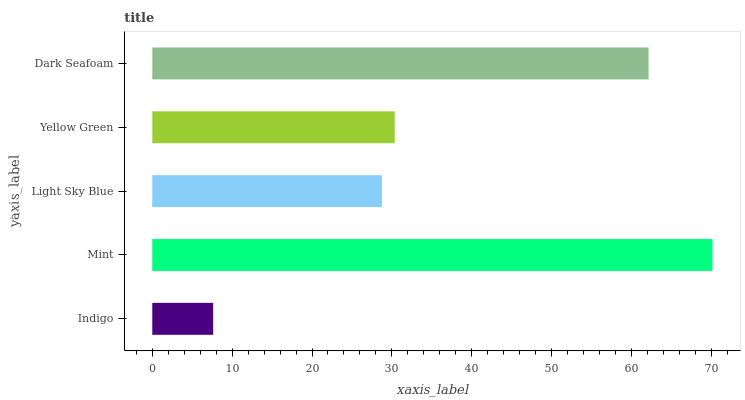Is Indigo the minimum?
Answer yes or no. Yes. Is Mint the maximum?
Answer yes or no. Yes. Is Light Sky Blue the minimum?
Answer yes or no. No. Is Light Sky Blue the maximum?
Answer yes or no. No. Is Mint greater than Light Sky Blue?
Answer yes or no. Yes. Is Light Sky Blue less than Mint?
Answer yes or no. Yes. Is Light Sky Blue greater than Mint?
Answer yes or no. No. Is Mint less than Light Sky Blue?
Answer yes or no. No. Is Yellow Green the high median?
Answer yes or no. Yes. Is Yellow Green the low median?
Answer yes or no. Yes. Is Indigo the high median?
Answer yes or no. No. Is Mint the low median?
Answer yes or no. No. 